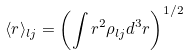<formula> <loc_0><loc_0><loc_500><loc_500>\langle r \rangle _ { l j } = \left ( \int r ^ { 2 } \rho _ { l j } d ^ { 3 } r \right ) ^ { 1 / 2 }</formula> 